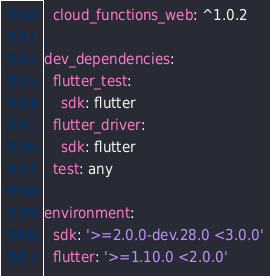Convert code to text. <code><loc_0><loc_0><loc_500><loc_500><_YAML_>  cloud_functions_web: ^1.0.2

dev_dependencies:
  flutter_test:
    sdk: flutter
  flutter_driver:
    sdk: flutter
  test: any

environment:
  sdk: '>=2.0.0-dev.28.0 <3.0.0'
  flutter: '>=1.10.0 <2.0.0'
</code> 